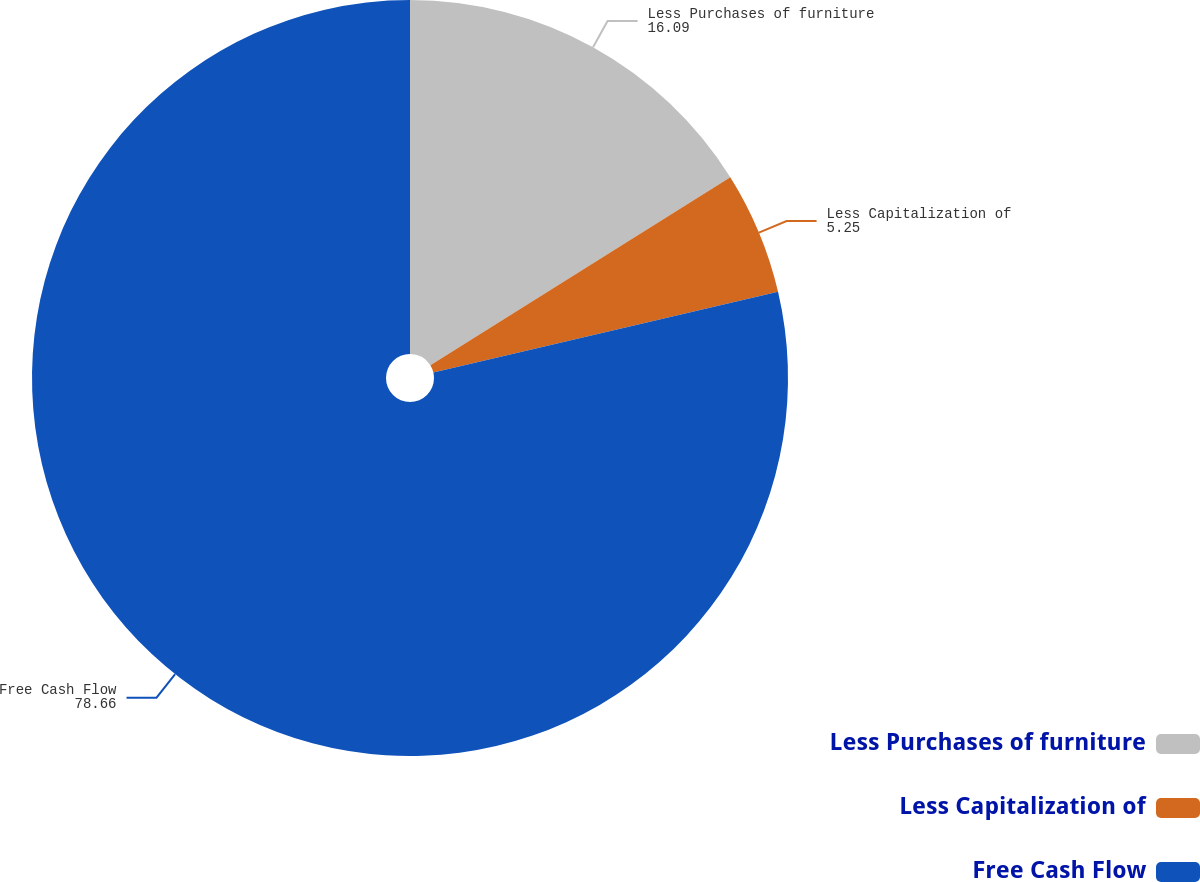<chart> <loc_0><loc_0><loc_500><loc_500><pie_chart><fcel>Less Purchases of furniture<fcel>Less Capitalization of<fcel>Free Cash Flow<nl><fcel>16.09%<fcel>5.25%<fcel>78.66%<nl></chart> 